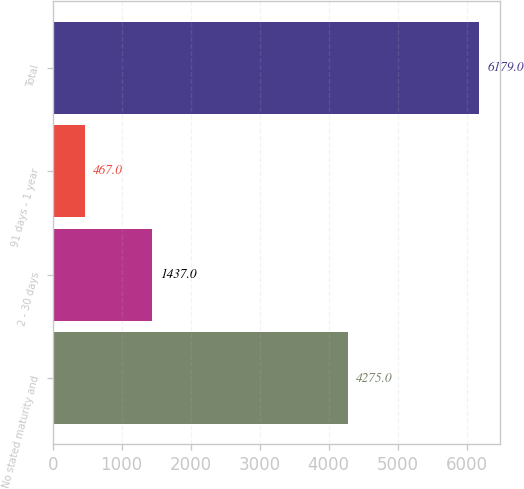Convert chart. <chart><loc_0><loc_0><loc_500><loc_500><bar_chart><fcel>No stated maturity and<fcel>2 - 30 days<fcel>91 days - 1 year<fcel>Total<nl><fcel>4275<fcel>1437<fcel>467<fcel>6179<nl></chart> 